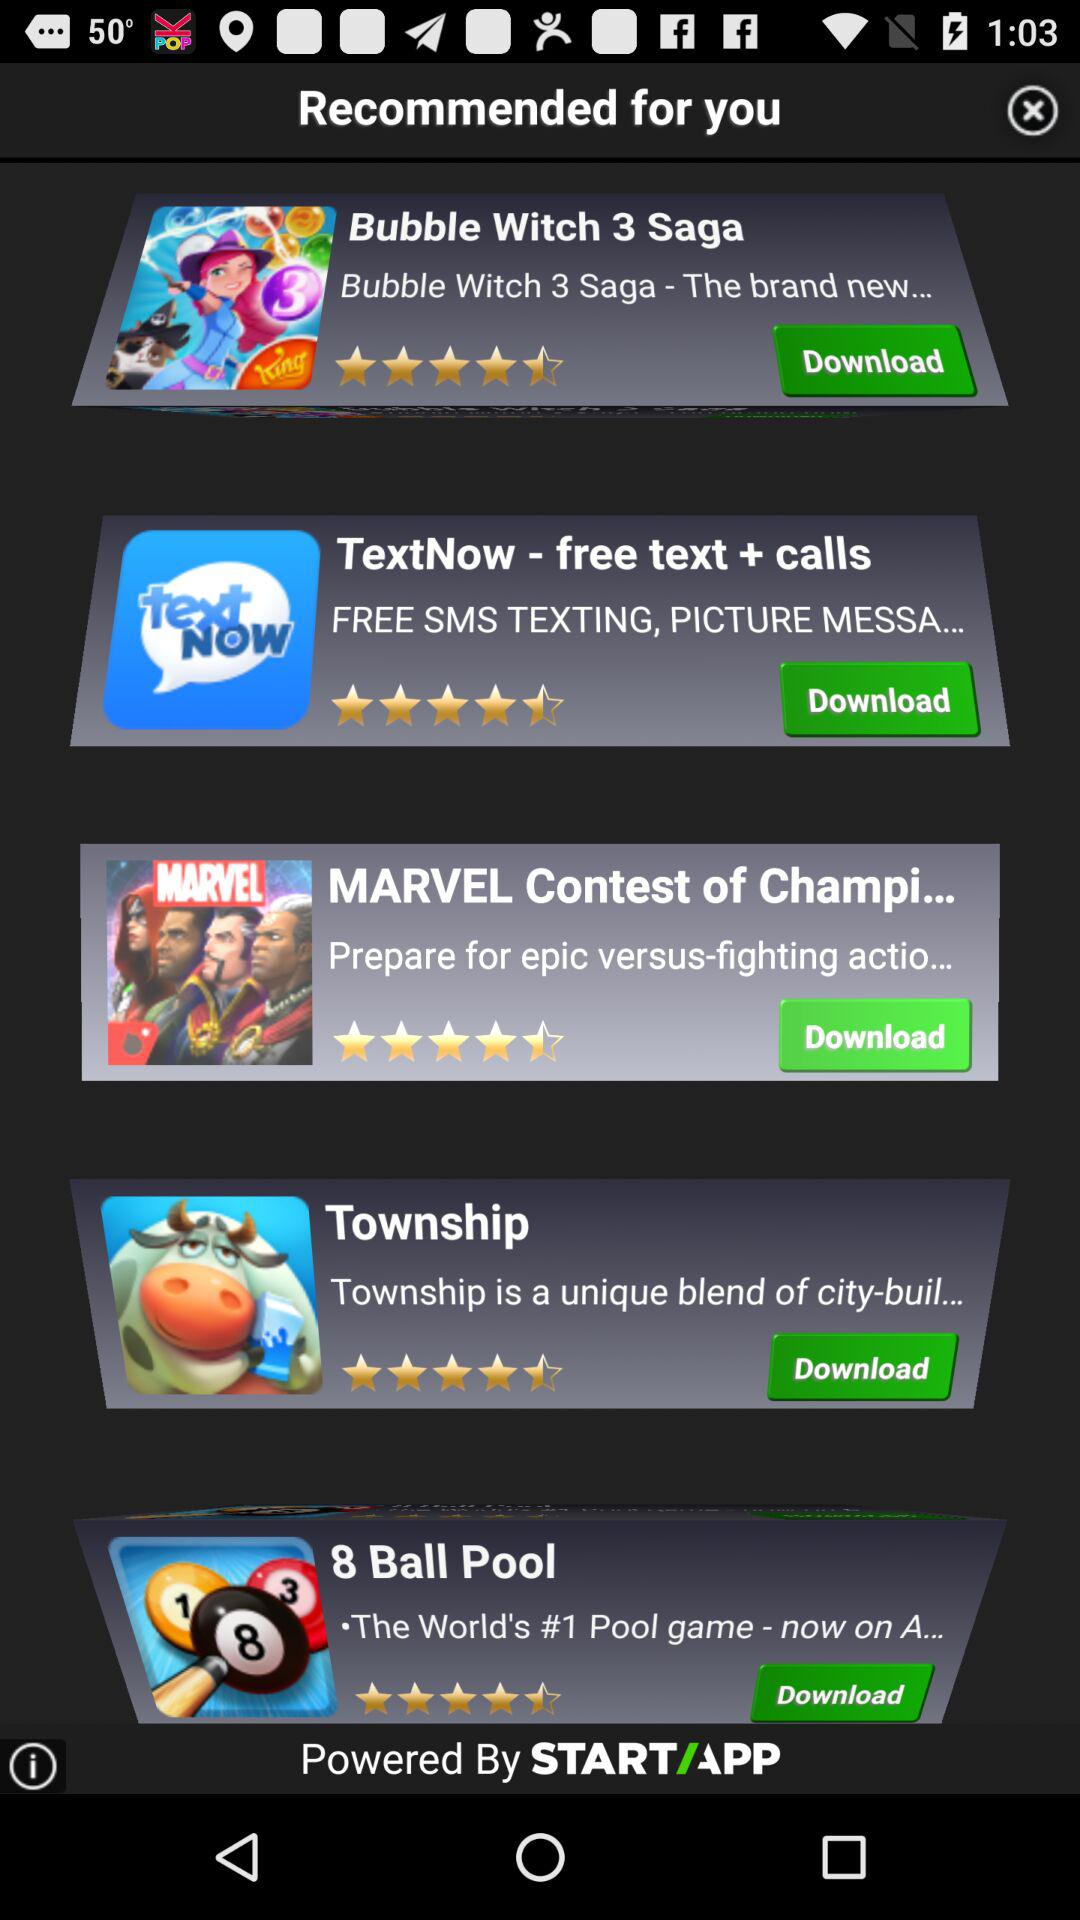How many stars are given to "Bubble Witch 3 Saga"? There are 4.5 stars given to "Bubble Witch 3 Saga". 